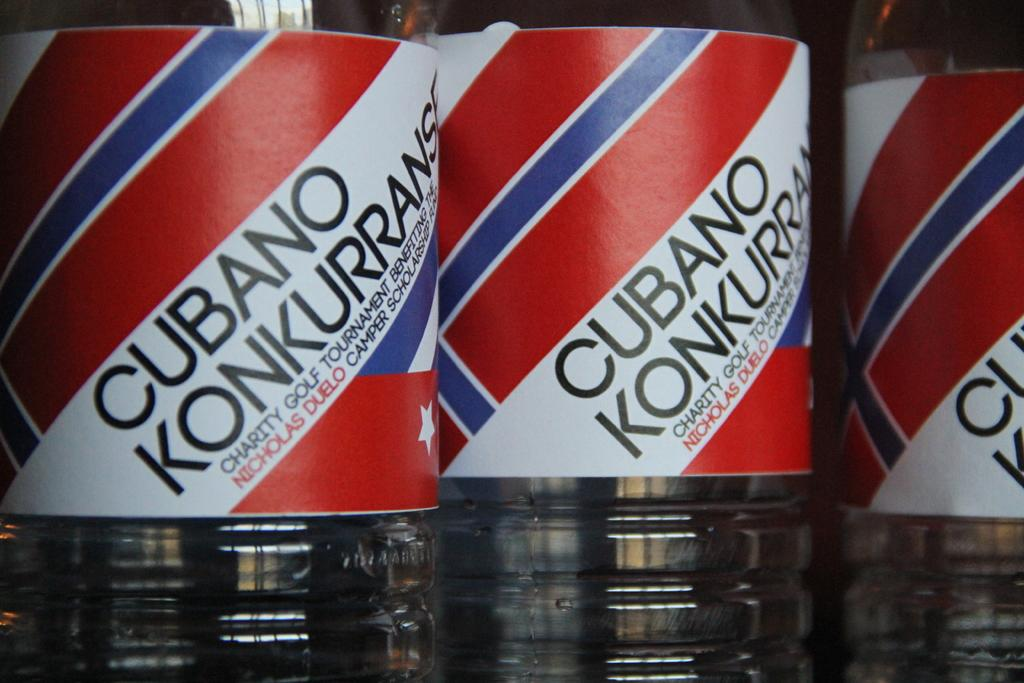Provide a one-sentence caption for the provided image. Three bottles of Cubano Konkurrans sit next to each other. 